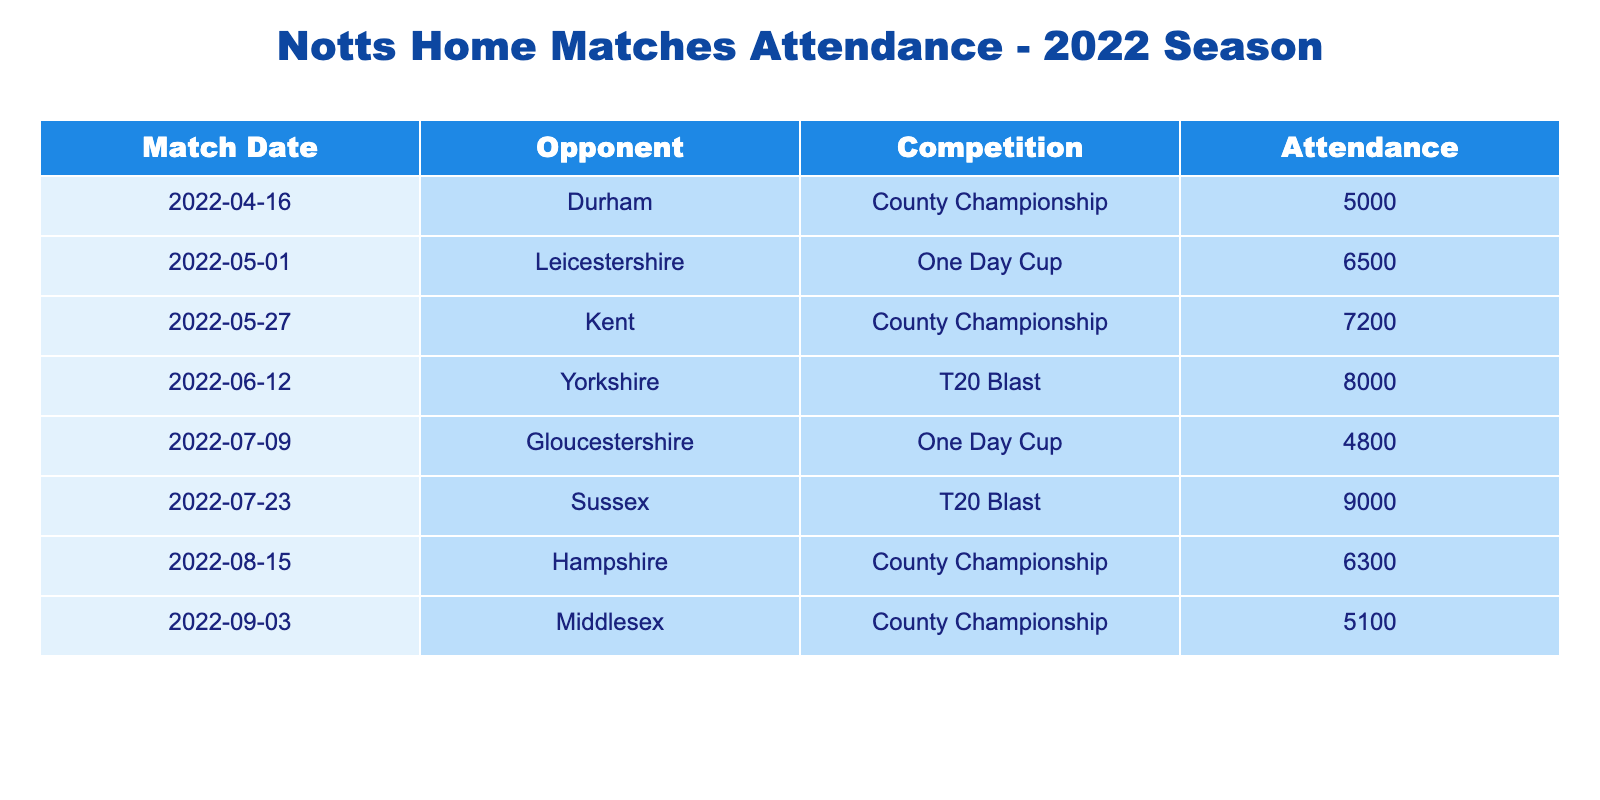What was the attendance for the match against Durham? The table shows the attendance for each match, and the row for the match against Durham (on April 16, 2022) lists the attendance as 5000.
Answer: 5000 Which match had the highest attendance? To determine the highest attendance, we look through each attendance figure in the table. The values for the matches are: 5000 (Durham), 6500 (Leicestershire), 7200 (Kent), 8000 (Yorkshire), 4800 (Gloucestershire), 9000 (Sussex), 6300 (Hampshire), and 5100 (Middlesex). The highest value is 9000 for the match against Sussex on July 23, 2022.
Answer: Sussex, 9000 What was the average attendance for Notts home matches in 2022? First, we sum all attendance figures: 5000 + 6500 + 7200 + 8000 + 4800 + 9000 + 6300 + 5100 = 49900. There are 8 matches, so we calculate the average by dividing the total attendance by the number of matches: 49900 / 8 = 6237.5.
Answer: 6237.5 Did Notts have a match with attendance lower than 5000? By checking each attendance figure in the table, we find the lowest attendance is 4800 for the match against Gloucestershire. Since 4800 is below 5000, the answer is yes.
Answer: Yes What was the difference in attendance between the matches against Kent and Hampshire? The table shows the attendance for the Kent match as 7200 and for the Hampshire match as 6300. We find the difference by subtracting the Hampshire attendance from the Kent attendance: 7200 - 6300 = 900.
Answer: 900 Which month had the most matches with more than 7000 attendees? Upon examining the matches by their dates, we find that the matches against Yorkshire (8000) and Sussex (9000) in July exceed 7000. Meanwhile, the only match above 7000 in other months are Leicestershire (6500 in May), Kent (7200 in May), and Hampshire (6300 in August). Thus, July has the most matches above 7000.
Answer: July How many One Day Cup matches were there, and what was their average attendance? From the table, there are two One Day Cup matches: against Leicestershire (6500) and Gloucestershire (4800). Summing these gives 6500 + 4800 = 11300. The average is then calculated as 11300 / 2 = 5650.
Answer: 5650 What was the attendance for the last match of the season, and who was the opponent? The last match of the season was against Middlesex on September 3, 2022, and the attendance for the match is 5100, as shown in the table.
Answer: 5100, Middlesex 